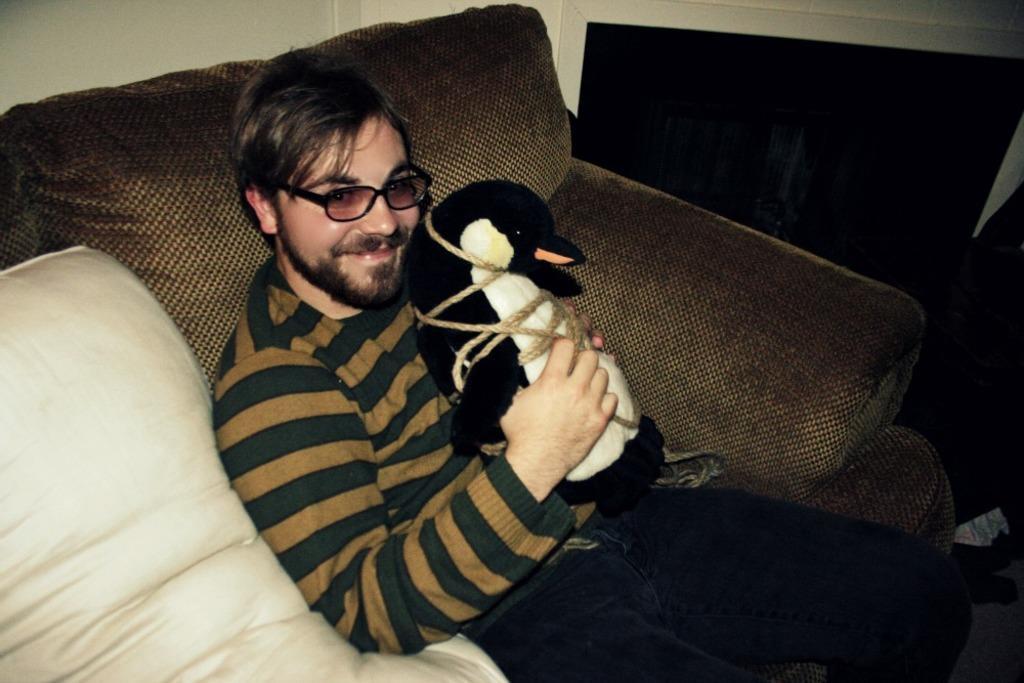Please provide a concise description of this image. In this image there is a man sitting, he is holding a toy, there is a pillow towards the left of the image, there is a couch, there is an object towards the right of the image, there is the wall towards the top of the image. 